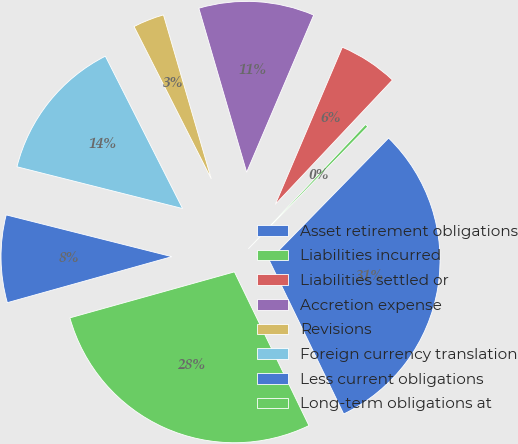<chart> <loc_0><loc_0><loc_500><loc_500><pie_chart><fcel>Asset retirement obligations<fcel>Liabilities incurred<fcel>Liabilities settled or<fcel>Accretion expense<fcel>Revisions<fcel>Foreign currency translation<fcel>Less current obligations<fcel>Long-term obligations at<nl><fcel>30.5%<fcel>0.29%<fcel>5.61%<fcel>10.93%<fcel>2.95%<fcel>13.6%<fcel>8.27%<fcel>27.84%<nl></chart> 